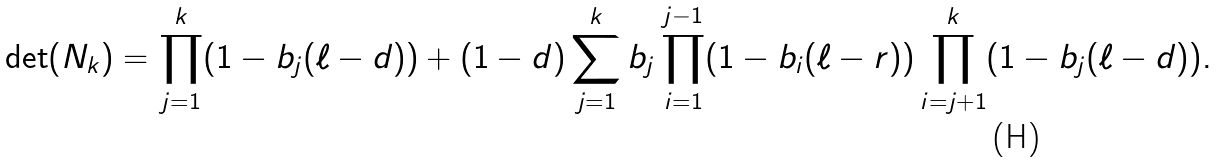<formula> <loc_0><loc_0><loc_500><loc_500>\det ( N _ { k } ) = \prod _ { j = 1 } ^ { k } ( 1 - b _ { j } ( \ell - d ) ) + ( 1 - d ) \sum _ { j = 1 } ^ { k } b _ { j } \prod _ { i = 1 } ^ { j - 1 } ( 1 - b _ { i } ( \ell - r ) ) \prod _ { i = j + 1 } ^ { k } ( 1 - b _ { j } ( \ell - d ) ) .</formula> 